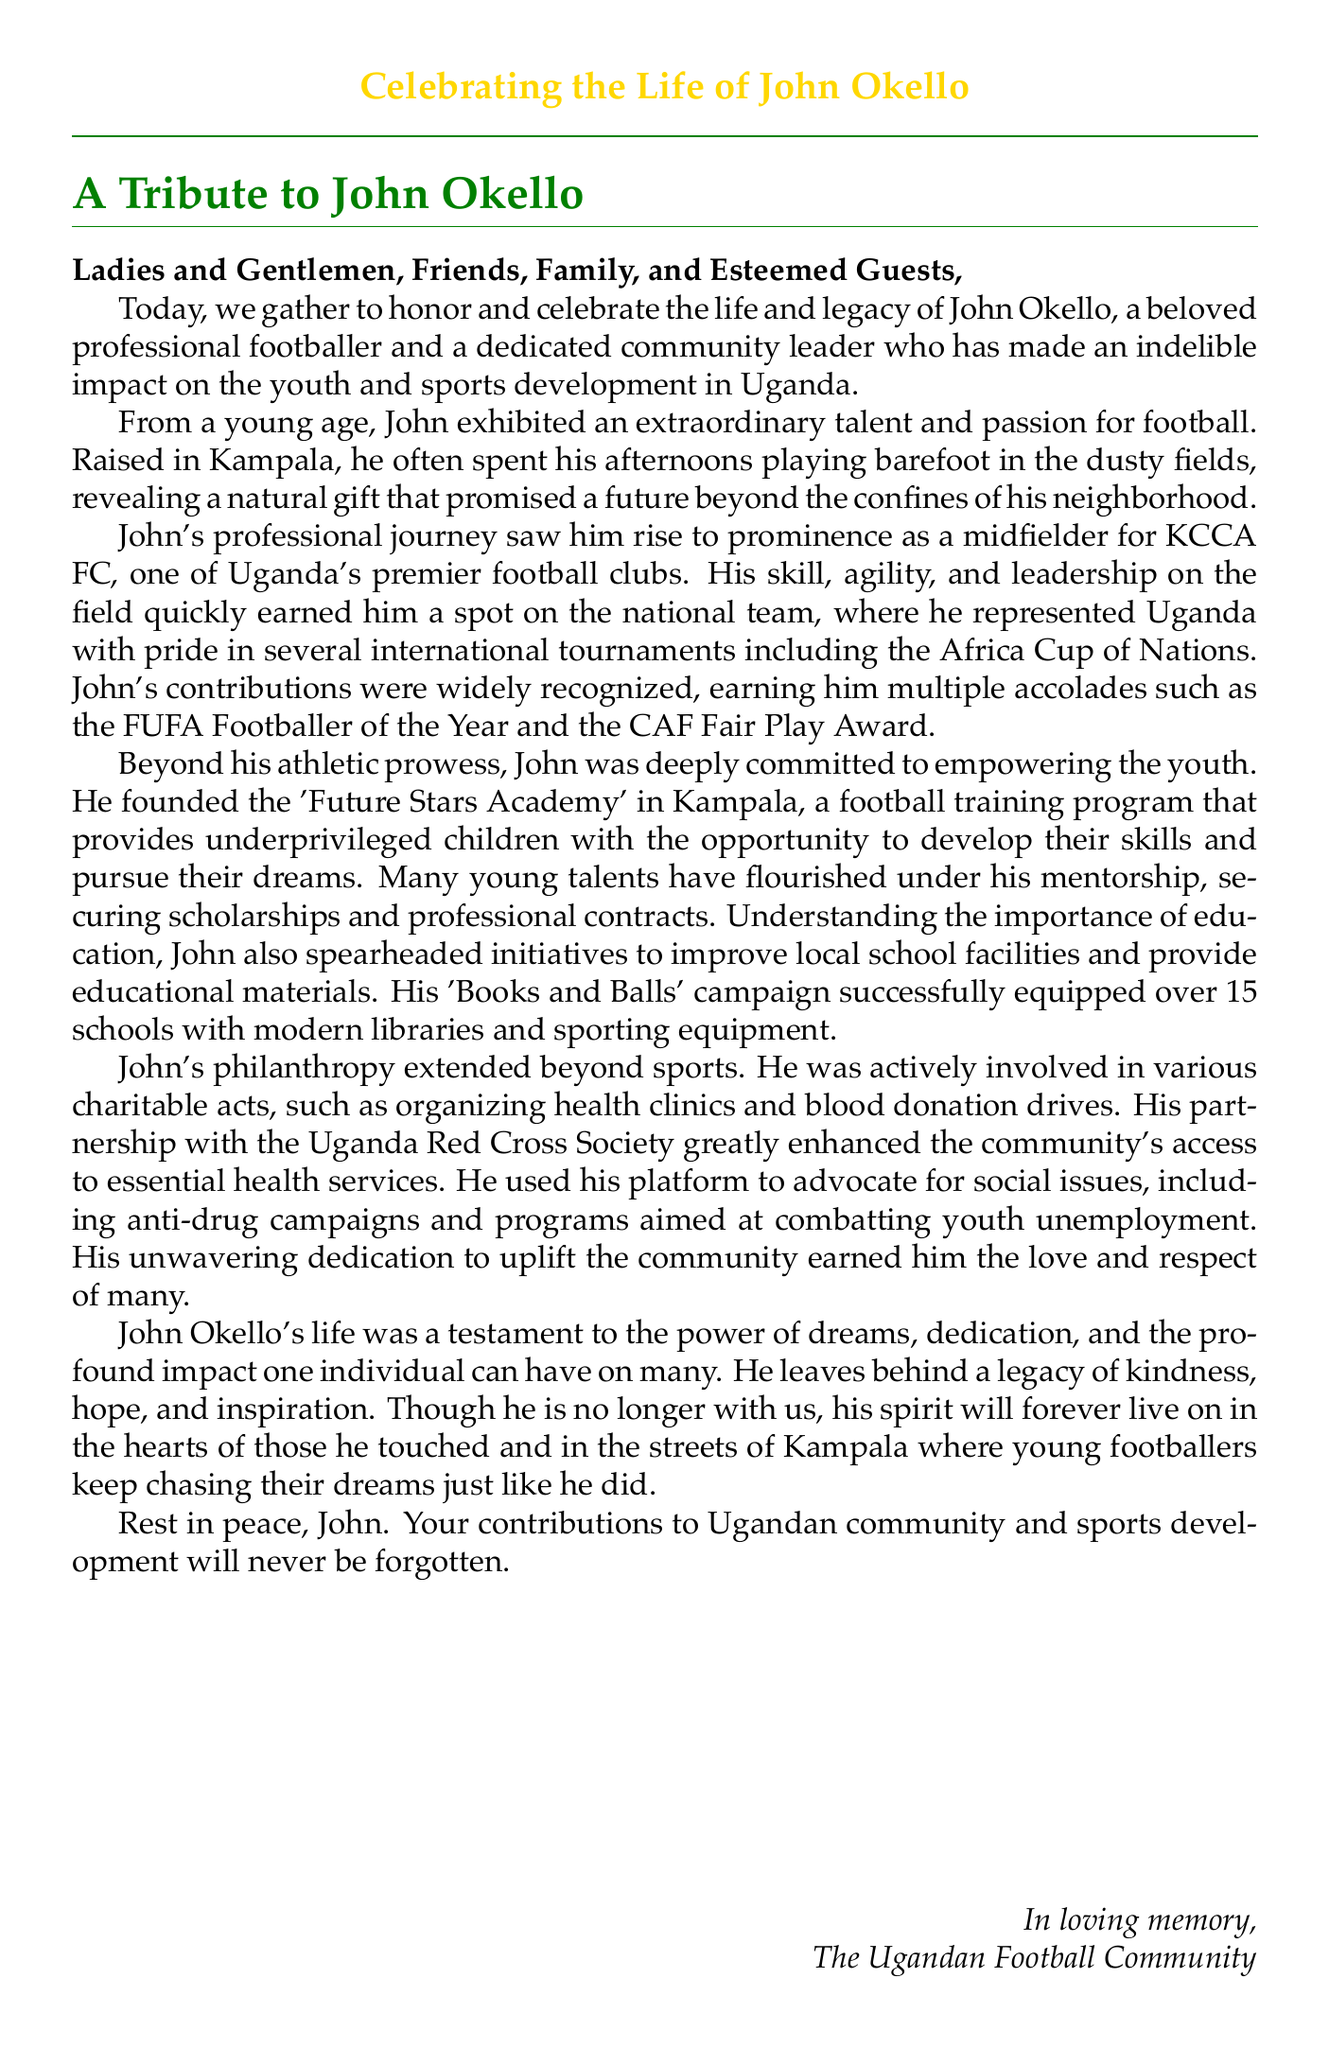What was John Okello's main role in football? John Okello was primarily a midfielder, which is stated in the document as part of his professional journey.
Answer: Midfielder For which club did John Okello play? The document mentions that he was a midfielder for KCCA FC, which is one of Uganda's premier football clubs.
Answer: KCCA FC What recognition did John Okello receive for his sportsmanship? The document states he earned the CAF Fair Play Award, among other accolades.
Answer: CAF Fair Play Award What was the name of the academy founded by John Okello? The document refers to the football training program he established as the 'Future Stars Academy'.
Answer: Future Stars Academy How many schools were equipped through John Okello's 'Books and Balls' campaign? The document specifies that over 15 schools were equipped with modern libraries and sporting equipment.
Answer: Over 15 schools What medical initiative did John Okello organize? He was involved in organizing health clinics, as mentioned in the document.
Answer: Health clinics What social issue did John Okello advocate against? The document highlights that he advocated for anti-drug campaigns as part of his community involvement.
Answer: Anti-drug campaigns How is John Okello remembered in the community? The document describes his legacy as one of kindness, hope, and inspiration, indicating how he is perceived by others.
Answer: Kindness, hope, and inspiration 